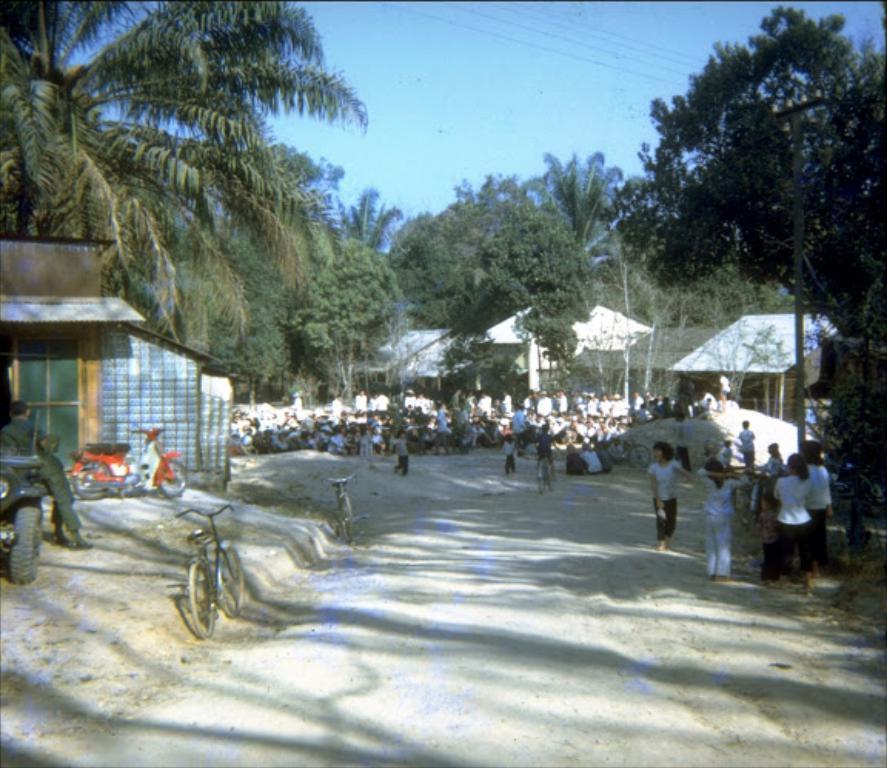How would you summarize this image in a sentence or two? In the right side few children are playing, these are the trees in the middle of an image. In the left side few cycles are parked. 